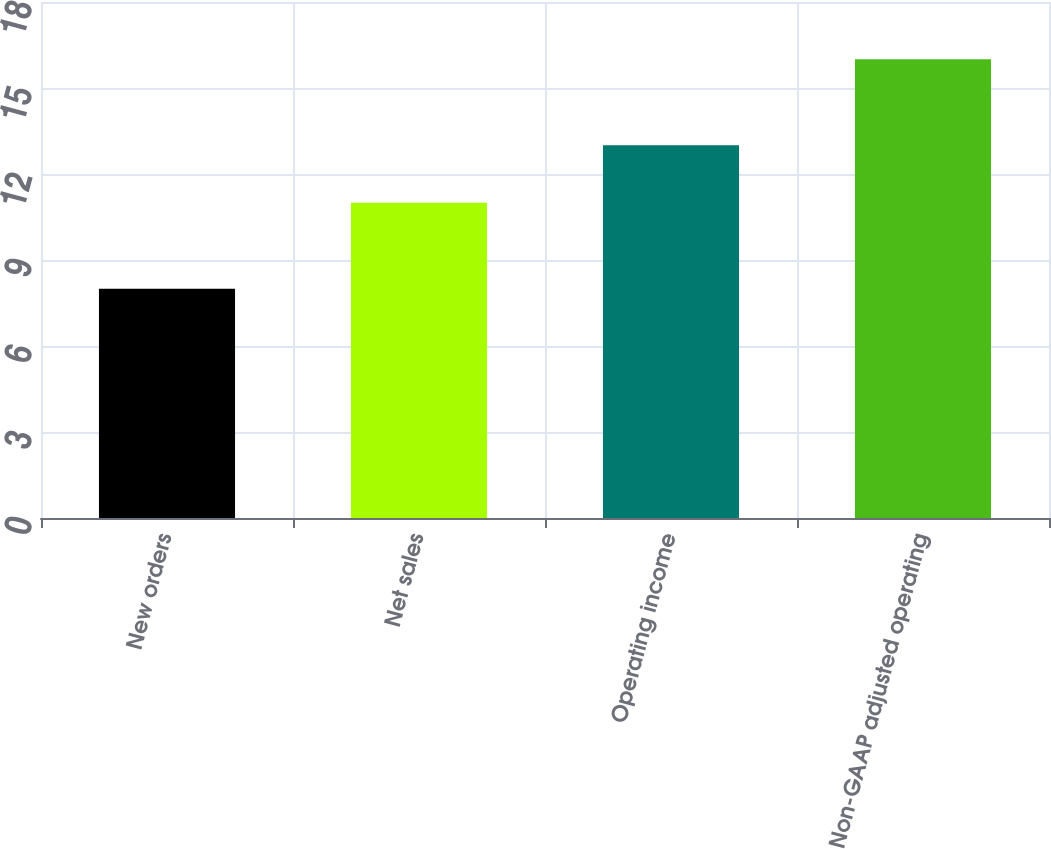Convert chart. <chart><loc_0><loc_0><loc_500><loc_500><bar_chart><fcel>New orders<fcel>Net sales<fcel>Operating income<fcel>Non-GAAP adjusted operating<nl><fcel>8<fcel>11<fcel>13<fcel>16<nl></chart> 